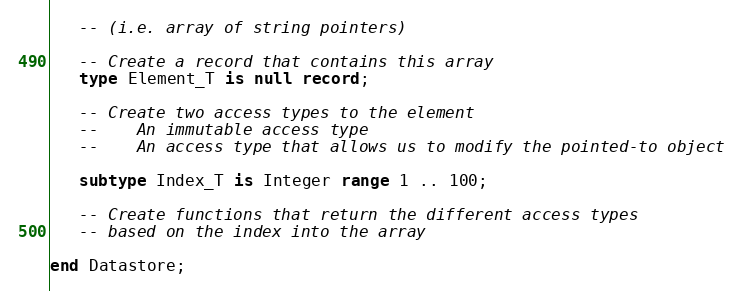Convert code to text. <code><loc_0><loc_0><loc_500><loc_500><_Ada_>   -- (i.e. array of string pointers)

   -- Create a record that contains this array
   type Element_T is null record;

   -- Create two access types to the element
   --    An immutable access type
   --    An access type that allows us to modify the pointed-to object

   subtype Index_T is Integer range 1 .. 100;

   -- Create functions that return the different access types
   -- based on the index into the array

end Datastore;
</code> 